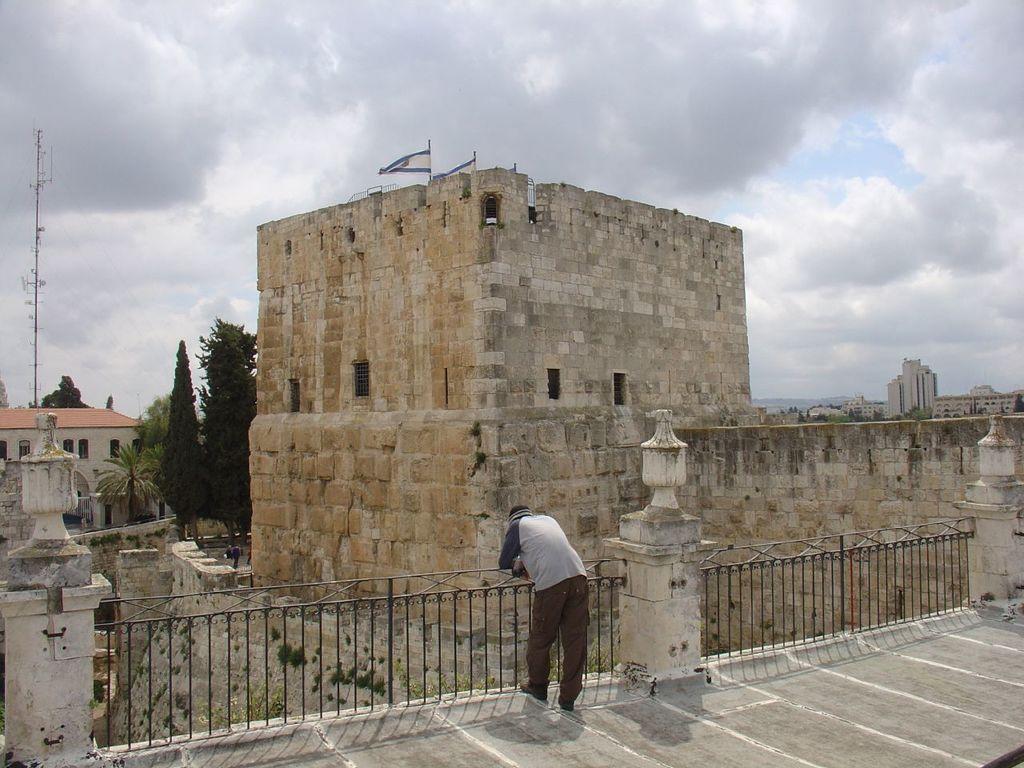Please provide a concise description of this image. In this image I can see a man and railings in the front. In the background I can see number of buildings, clouds and the sky. I can also see two flags in the centre of this image. 